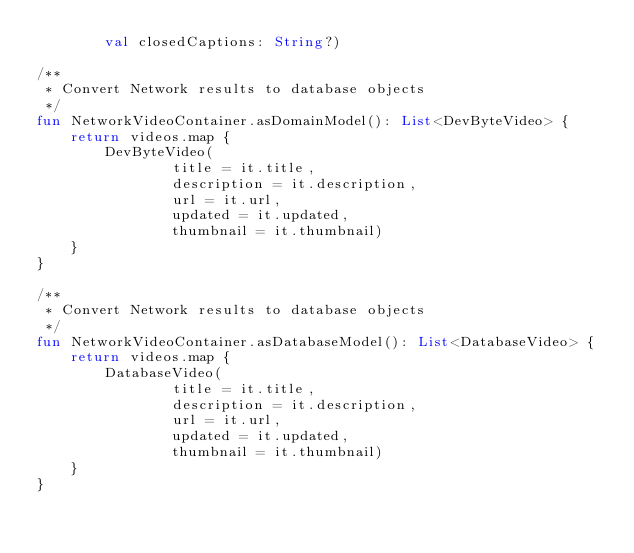<code> <loc_0><loc_0><loc_500><loc_500><_Kotlin_>        val closedCaptions: String?)

/**
 * Convert Network results to database objects
 */
fun NetworkVideoContainer.asDomainModel(): List<DevByteVideo> {
    return videos.map {
        DevByteVideo(
                title = it.title,
                description = it.description,
                url = it.url,
                updated = it.updated,
                thumbnail = it.thumbnail)
    }
}

/**
 * Convert Network results to database objects
 */
fun NetworkVideoContainer.asDatabaseModel(): List<DatabaseVideo> {
    return videos.map {
        DatabaseVideo(
                title = it.title,
                description = it.description,
                url = it.url,
                updated = it.updated,
                thumbnail = it.thumbnail)
    }
}</code> 